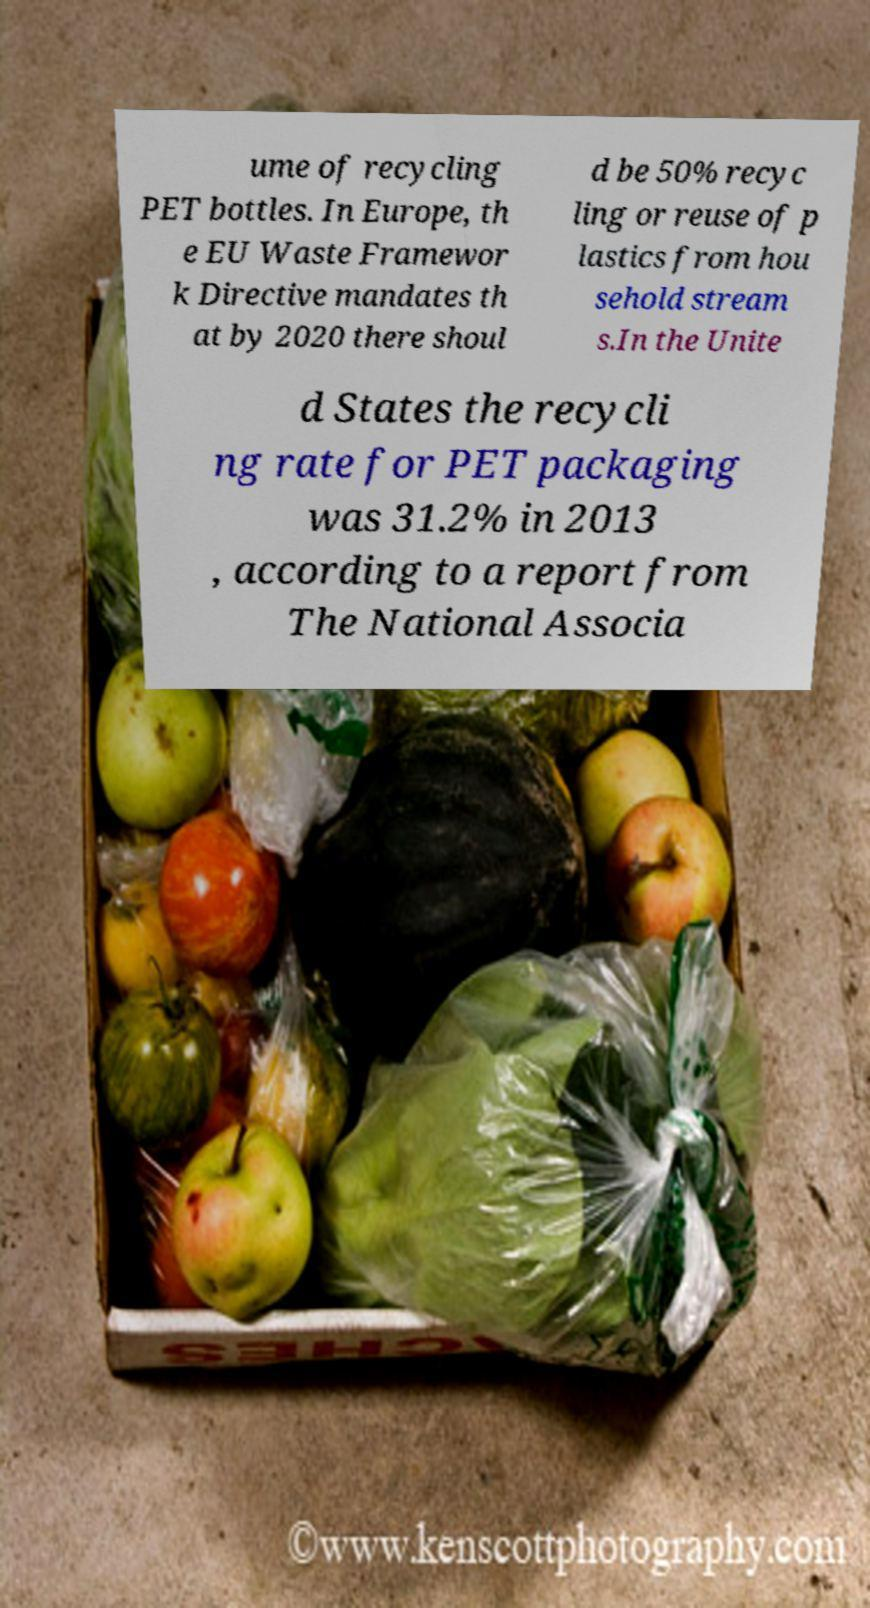Please identify and transcribe the text found in this image. ume of recycling PET bottles. In Europe, th e EU Waste Framewor k Directive mandates th at by 2020 there shoul d be 50% recyc ling or reuse of p lastics from hou sehold stream s.In the Unite d States the recycli ng rate for PET packaging was 31.2% in 2013 , according to a report from The National Associa 